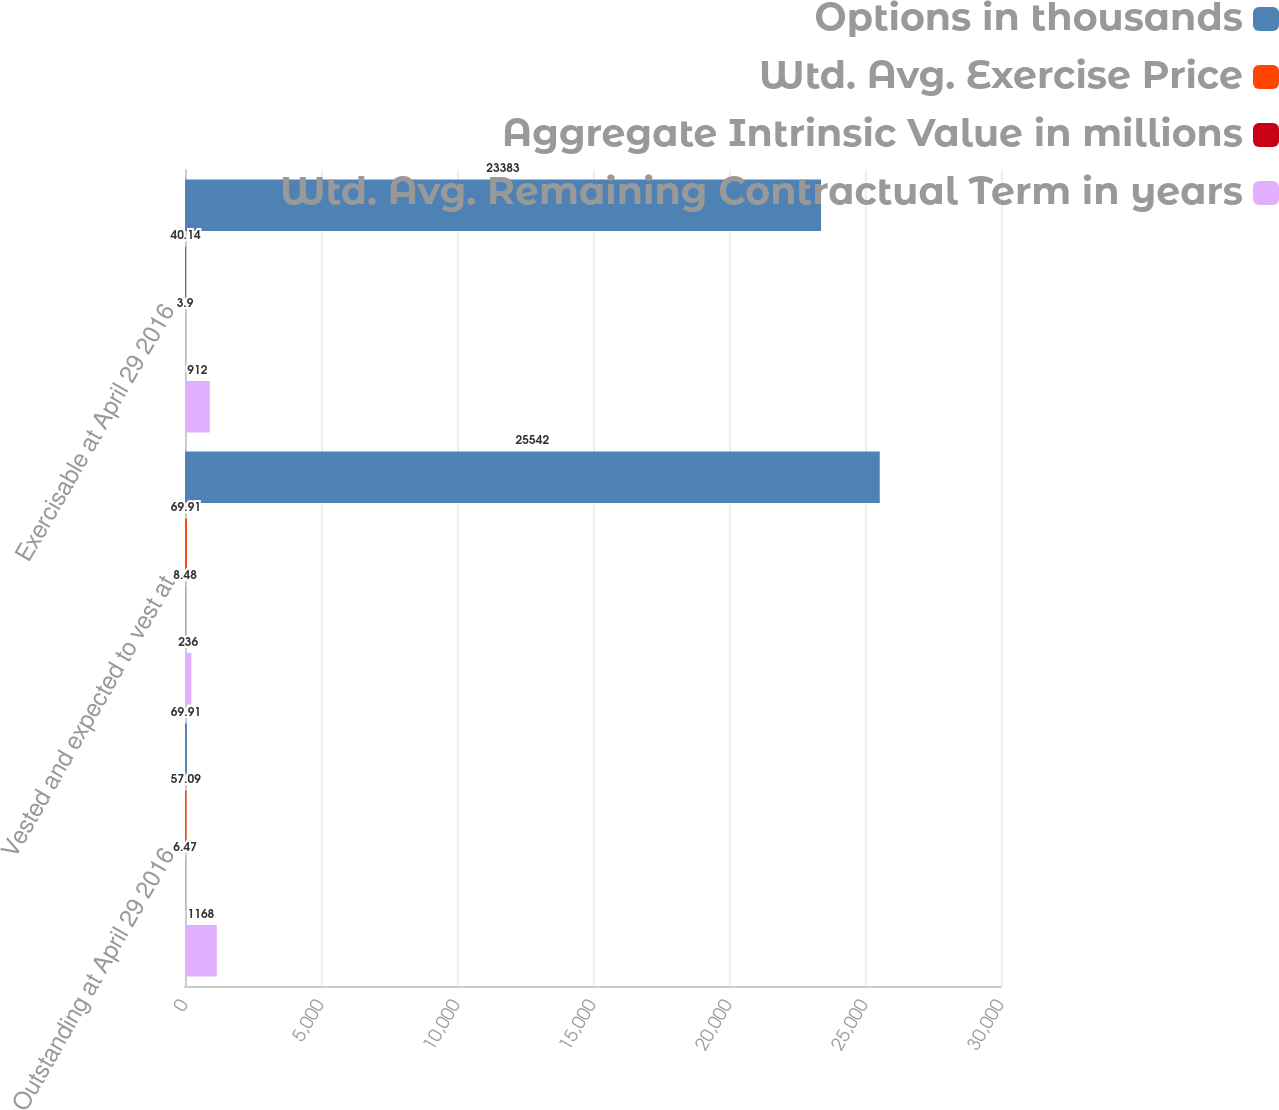<chart> <loc_0><loc_0><loc_500><loc_500><stacked_bar_chart><ecel><fcel>Outstanding at April 29 2016<fcel>Vested and expected to vest at<fcel>Exercisable at April 29 2016<nl><fcel>Options in thousands<fcel>69.91<fcel>25542<fcel>23383<nl><fcel>Wtd. Avg. Exercise Price<fcel>57.09<fcel>69.91<fcel>40.14<nl><fcel>Aggregate Intrinsic Value in millions<fcel>6.47<fcel>8.48<fcel>3.9<nl><fcel>Wtd. Avg. Remaining Contractual Term in years<fcel>1168<fcel>236<fcel>912<nl></chart> 